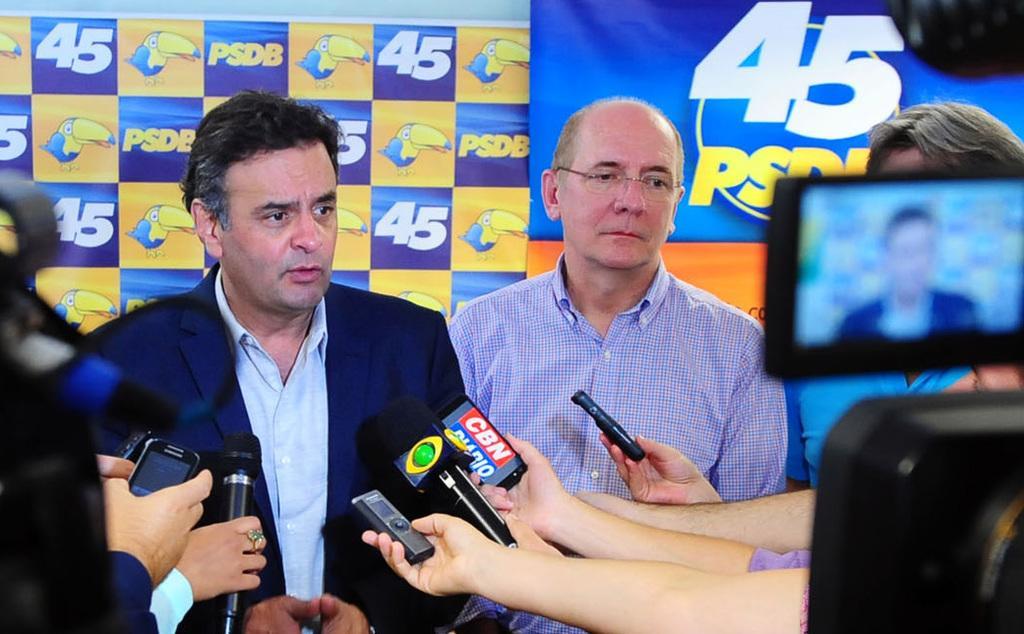In one or two sentences, can you explain what this image depicts? In the picture I can see people are standing among them some are holding microphones and some other objects. In the background I can see banners. 